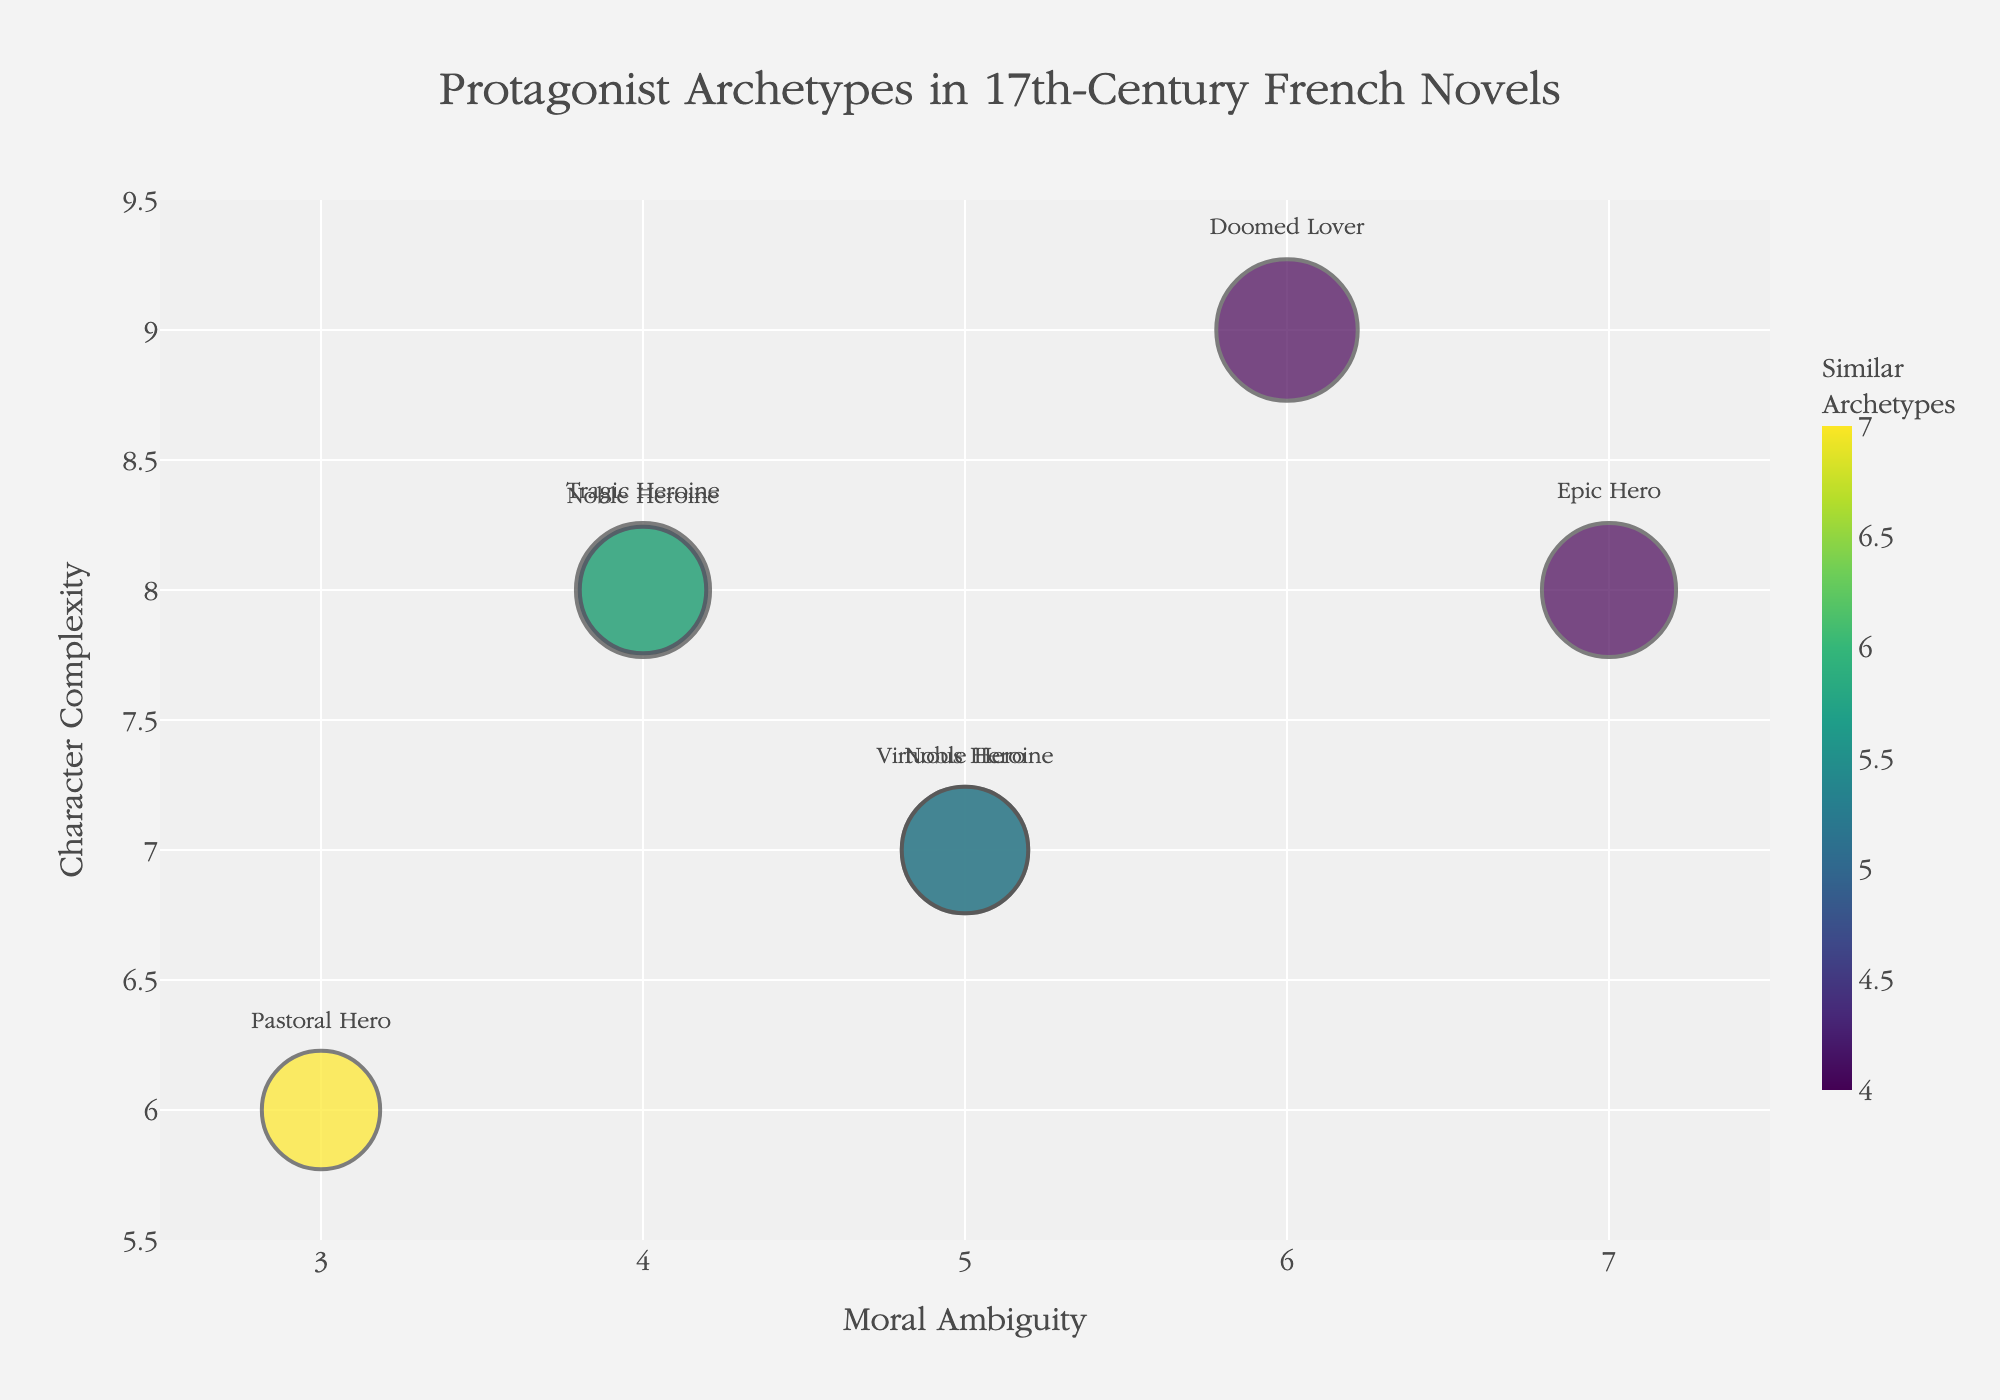How many novels are analyzed in the bubble chart? Count the number of bubbles in the chart. Each bubble represents a novel.
Answer: 7 Which novel has the highest character complexity? Check the bubble that is positioned highest on the y-axis (Character Complexity).
Answer: "Phèdre" What is the range of moral ambiguity values in the chart? Identify the minimum and maximum values on the x-axis (Moral Ambiguity).
Answer: 3 to 7 Which protagonist archetype has the greatest influence on the plot? Look for the largest bubble, as size indicates Influence on Plot.
Answer: "Doomed Lover" from "Phèdre" List the novels with a moral ambiguity value of 5. Find the bubbles located at x = 5 and note the titles.
Answer: "Le Cid", "Clélie" Which novel has a protagonist archetype that is both highly complex and has high moral ambiguity? Look for a bubble that is high on both the y-axis (Character Complexity) and x-axis (Moral Ambiguity).
Answer: "Artamène ou le Grand Cyrus" How does the character complexity of "The Princess of Clèves" compare to that of "L'Astrée"? Compare the y-axis values of both bubbles. "The Princess of Clèves" is 8, and "L'Astrée" is 6.
Answer: Higher (8 vs 6) Which novel's protagonist has the lowest complexity but a relatively high number of similar archetypes? Look for the bubble with the lowest position on the y-axis (Character Complexity) that also has a relatively high color value.
Answer: "L'Astrée" What is the aggregated influence on the plot of "The Princess of Clèves" and "Phèdre"? Sum the Influence on Plot values of both novels (9 + 10).
Answer: 19 List the titles of novels with an epic or noble protagonist archetype. Identify the bubbles with archetypes mentioned as "Epic Hero" or containing "Noble Hero".
Answer: "Le Cid", "Artamène ou le Grand Cyrus", "La Princesse de Montpensier" 